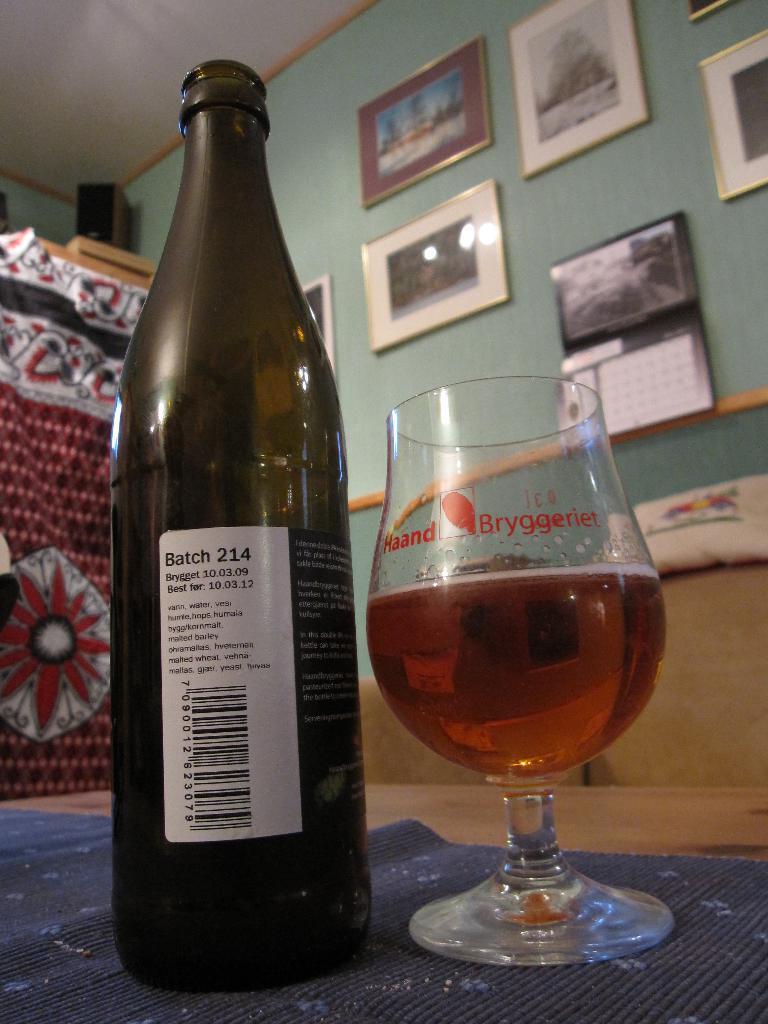Describe this image in one or two sentences. In this picture I can see there is a beer bottle and a beer glass placed on a surface and there is a wall in the backdrop and there are few photo frames and a calendar placed on the wall and there is a red and white cloth at left side. 